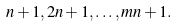<formula> <loc_0><loc_0><loc_500><loc_500>n + 1 , 2 n + 1 , \dots , m n + 1 .</formula> 